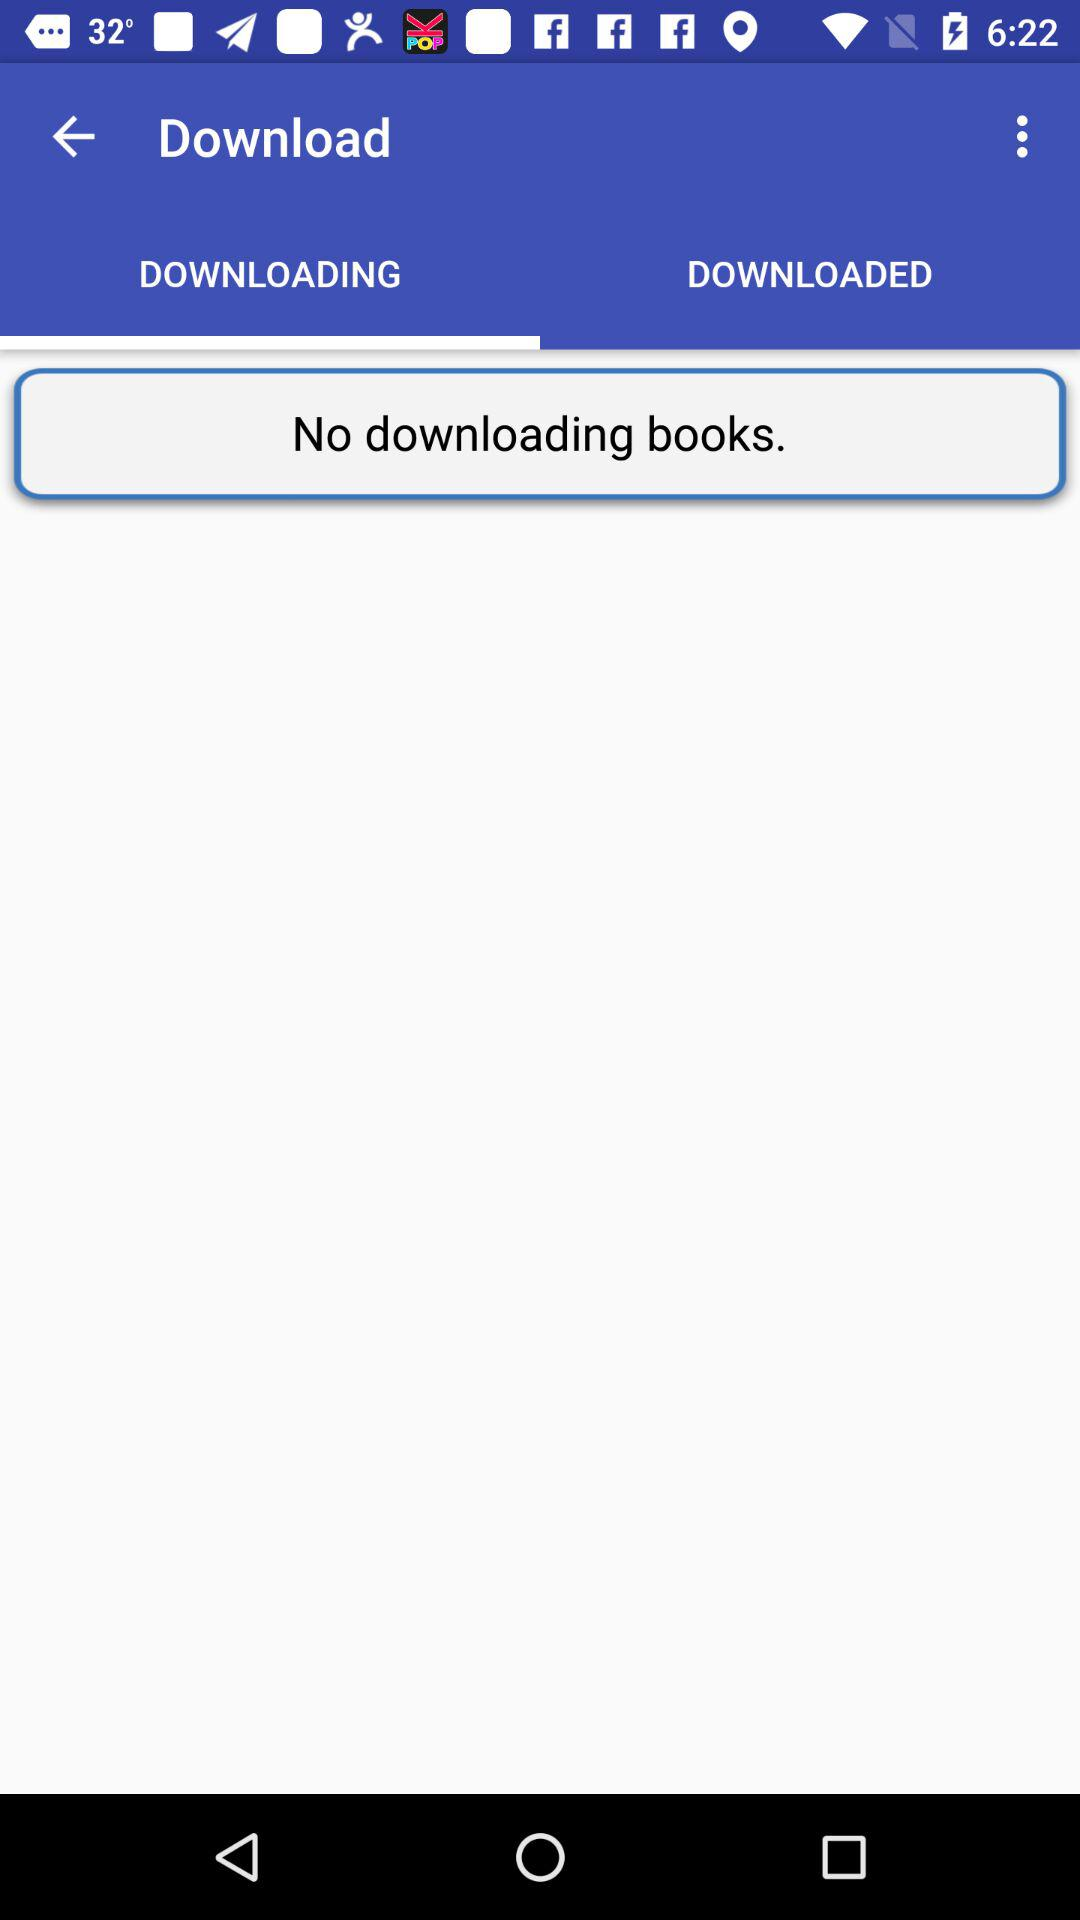Which tab is selected? The selected tab is "DOWNLOADING". 